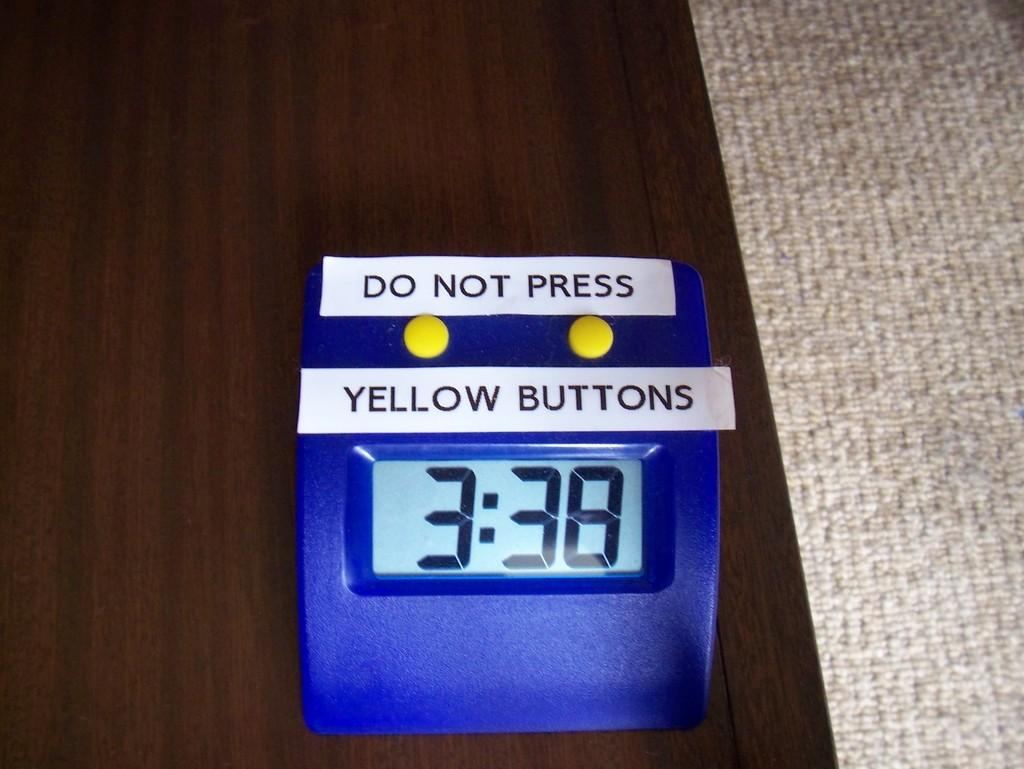Provide a one-sentence caption for the provided image. A clock with added labels of Do Not Press Yellow Button is on a brown table. 